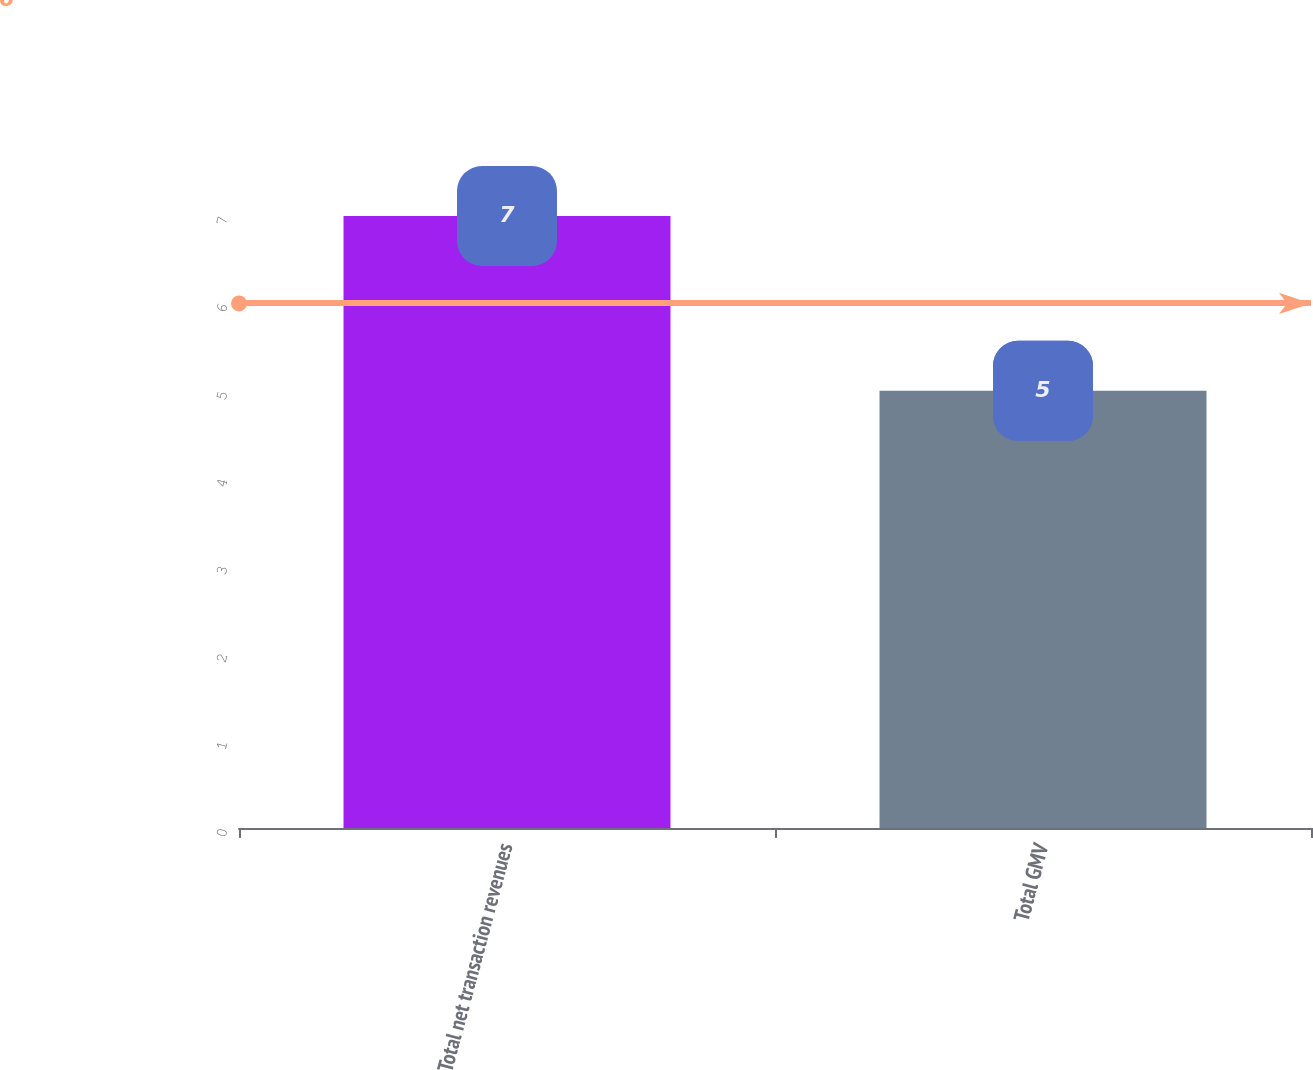Convert chart to OTSL. <chart><loc_0><loc_0><loc_500><loc_500><bar_chart><fcel>Total net transaction revenues<fcel>Total GMV<nl><fcel>7<fcel>5<nl></chart> 